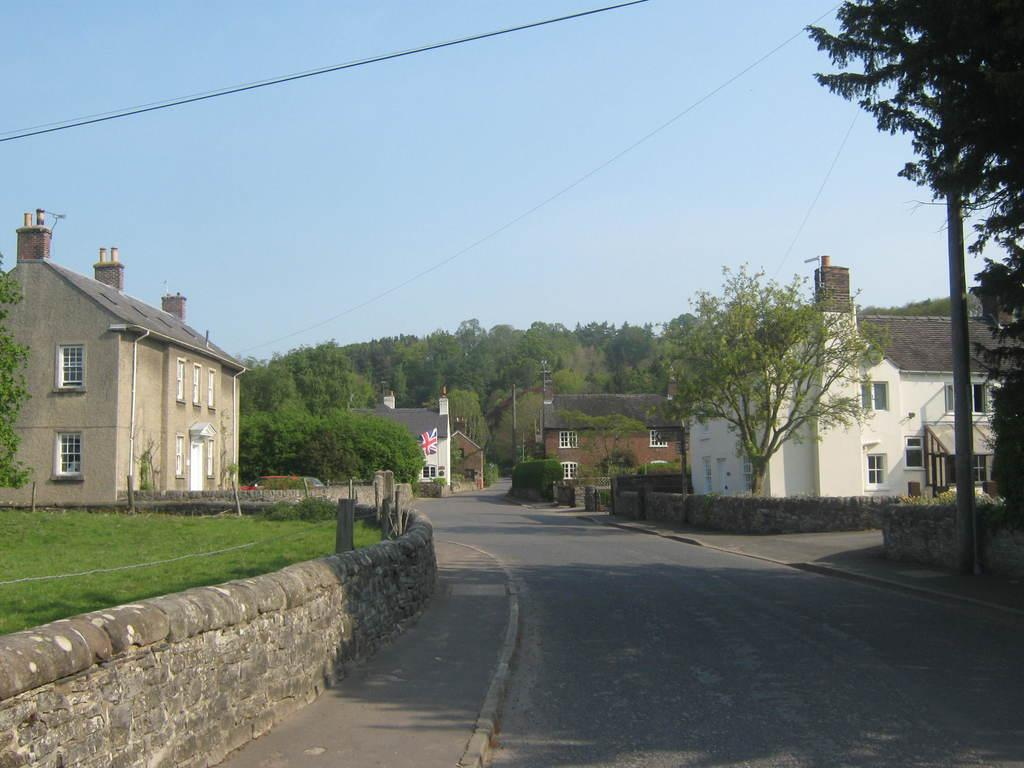What type of natural elements can be seen in the image? There are trees in the image. What type of man-made structures are present in the image? There are buildings in the image. What object is present that might be used for supporting or attaching something? There is a pole in the image. What type of lighting is present in the image? There is a pole light in the image. How would you describe the sky in the image? The sky is blue and cloudy in the image. What type of sack is being used to carry the force in the image? There is no sack or force present in the image. What type of home is visible in the image? The image does not show a home; it features trees, buildings, a pole, a pole light, and a blue and cloudy sky. 